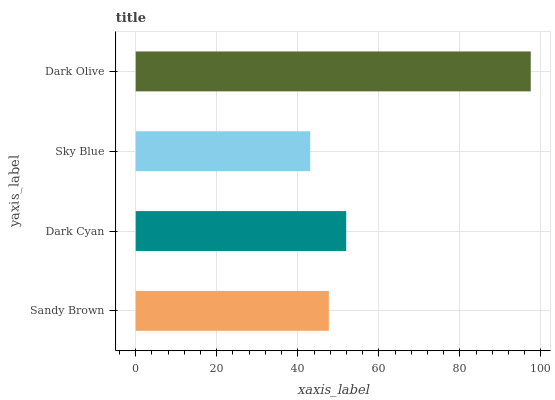Is Sky Blue the minimum?
Answer yes or no. Yes. Is Dark Olive the maximum?
Answer yes or no. Yes. Is Dark Cyan the minimum?
Answer yes or no. No. Is Dark Cyan the maximum?
Answer yes or no. No. Is Dark Cyan greater than Sandy Brown?
Answer yes or no. Yes. Is Sandy Brown less than Dark Cyan?
Answer yes or no. Yes. Is Sandy Brown greater than Dark Cyan?
Answer yes or no. No. Is Dark Cyan less than Sandy Brown?
Answer yes or no. No. Is Dark Cyan the high median?
Answer yes or no. Yes. Is Sandy Brown the low median?
Answer yes or no. Yes. Is Sandy Brown the high median?
Answer yes or no. No. Is Sky Blue the low median?
Answer yes or no. No. 